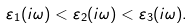Convert formula to latex. <formula><loc_0><loc_0><loc_500><loc_500>\varepsilon _ { 1 } ( i \omega ) < \varepsilon _ { 2 } ( i \omega ) < \varepsilon _ { 3 } ( i \omega ) .</formula> 